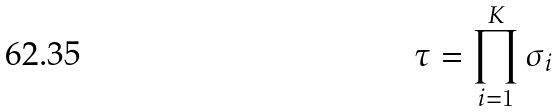Convert formula to latex. <formula><loc_0><loc_0><loc_500><loc_500>\tau = \prod _ { i = 1 } ^ { K } \sigma _ { i }</formula> 